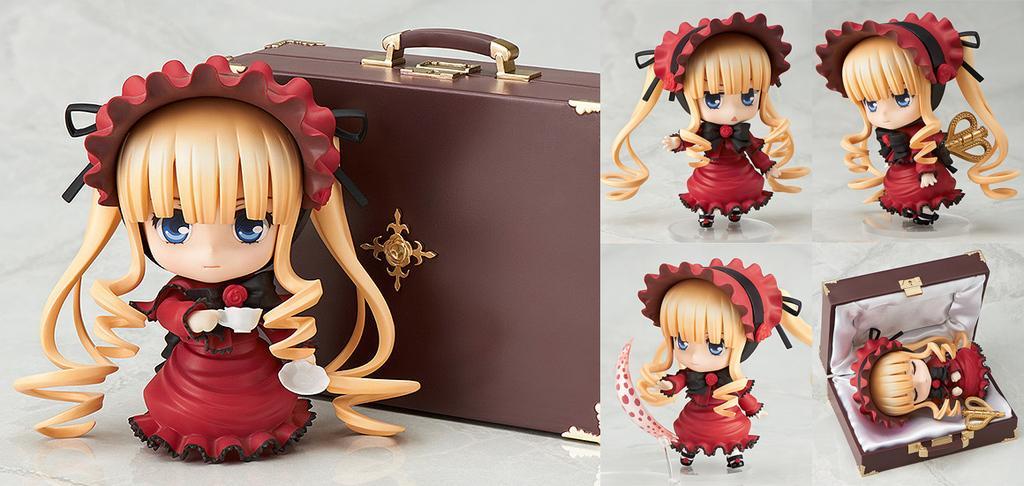Please provide a concise description of this image. This is a collage. On the first image there is a doll. Behind that there is a suitcase. On the other image there are dolls and a suitcase. Inside that there is a doll 